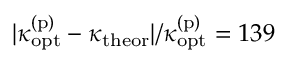Convert formula to latex. <formula><loc_0><loc_0><loc_500><loc_500>| \kappa _ { o p t } ^ { ( p ) } - \kappa _ { t h e o r } | / \kappa _ { o p t } ^ { ( p ) } = 1 3 9 \</formula> 